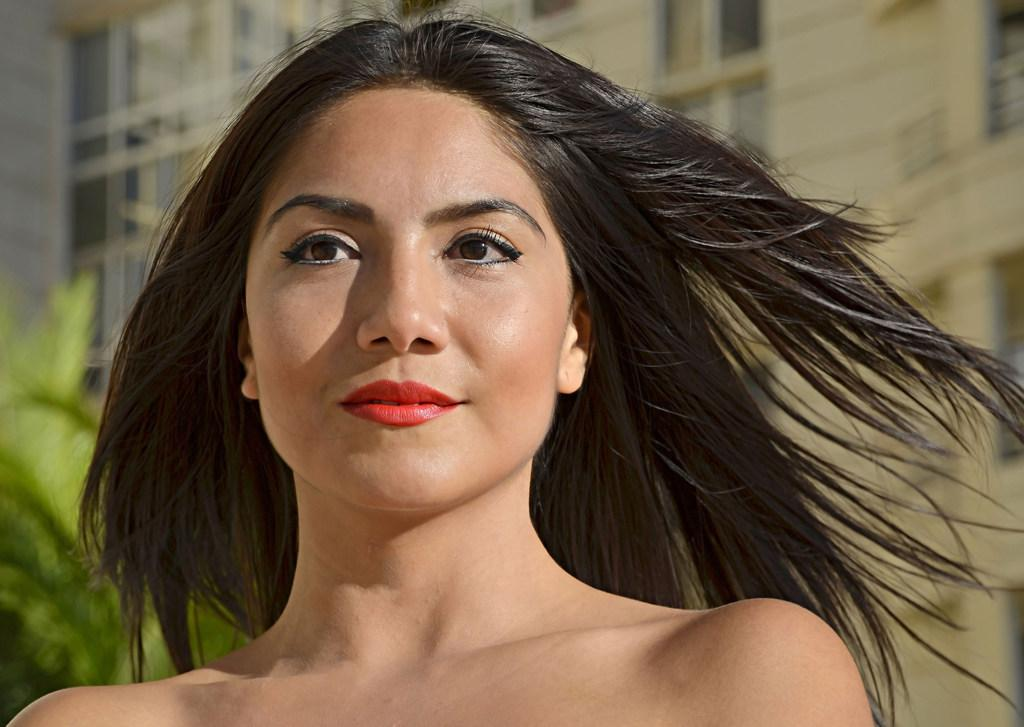Who is present in the image? There is a woman in the image. What can be seen in the background of the image? There is a building and a tree in the background of the image. What is the weight of the shirt the woman is wearing in the image? There is no shirt mentioned in the image, and therefore no weight can be determined. 